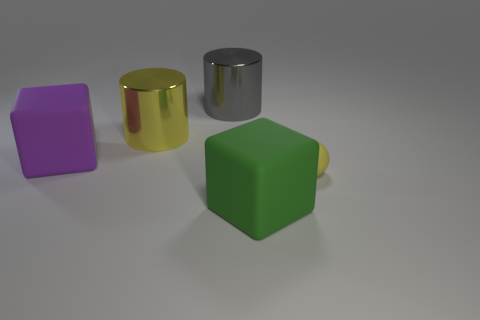Aside from matte and shiny, what other textures are visible in the objects? In addition to the matte green cube and shiny cylinders, the purple object seems to have a smooth, almost satin-like finish with soft reflections, suggesting a slightly glossy texture. 